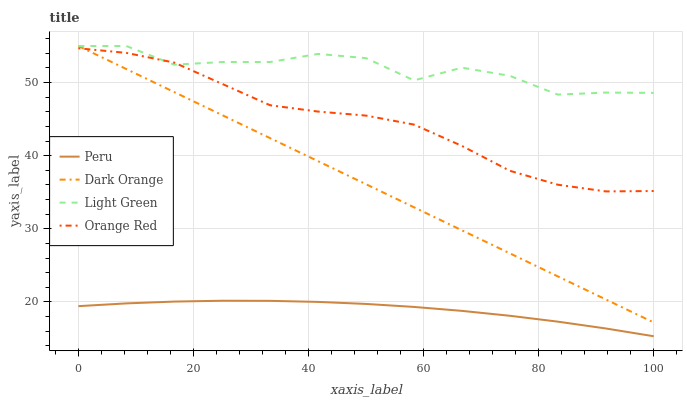Does Light Green have the minimum area under the curve?
Answer yes or no. No. Does Peru have the maximum area under the curve?
Answer yes or no. No. Is Peru the smoothest?
Answer yes or no. No. Is Peru the roughest?
Answer yes or no. No. Does Light Green have the lowest value?
Answer yes or no. No. Does Peru have the highest value?
Answer yes or no. No. Is Peru less than Light Green?
Answer yes or no. Yes. Is Orange Red greater than Peru?
Answer yes or no. Yes. Does Peru intersect Light Green?
Answer yes or no. No. 